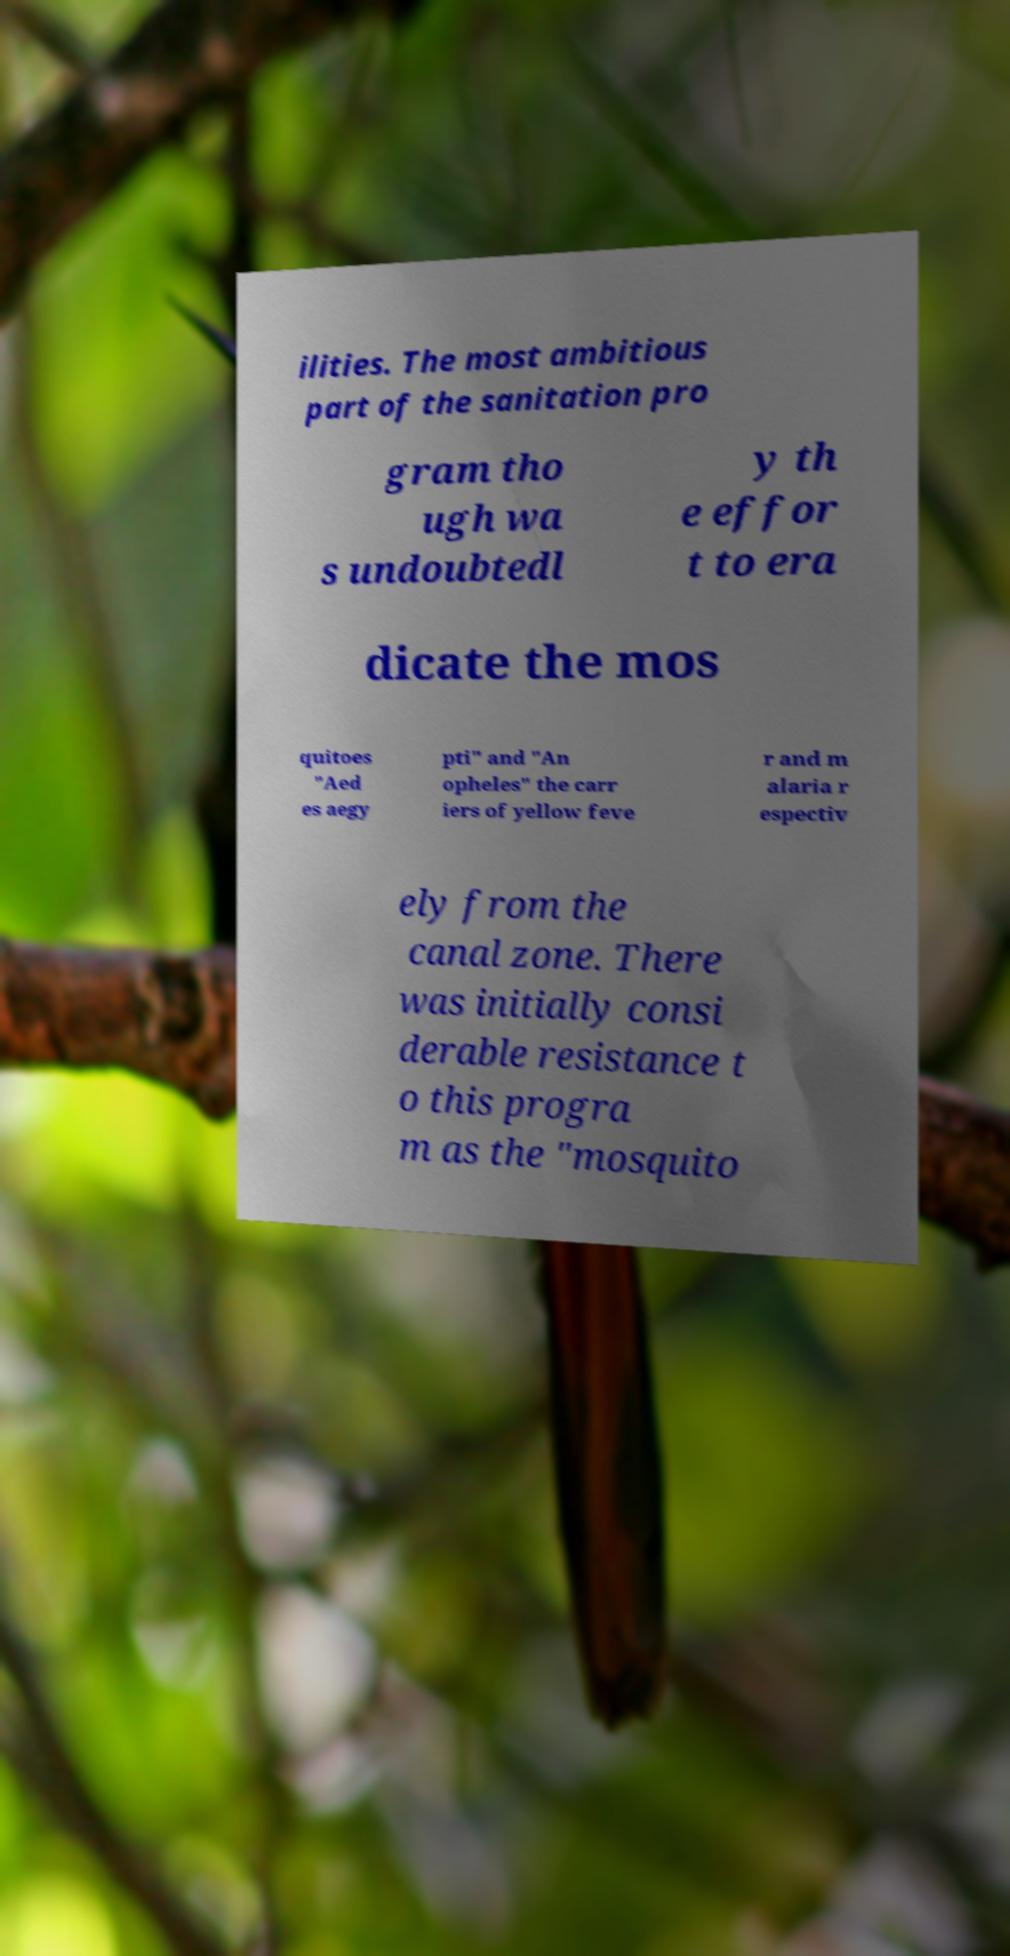Please identify and transcribe the text found in this image. ilities. The most ambitious part of the sanitation pro gram tho ugh wa s undoubtedl y th e effor t to era dicate the mos quitoes "Aed es aegy pti" and "An opheles" the carr iers of yellow feve r and m alaria r espectiv ely from the canal zone. There was initially consi derable resistance t o this progra m as the "mosquito 